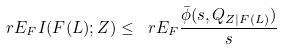Convert formula to latex. <formula><loc_0><loc_0><loc_500><loc_500>\ r E _ { F } I ( F ( L ) ; Z ) \leq \ r E _ { F } \frac { \bar { \phi } ( s , Q _ { Z | F ( L ) } ) } { s }</formula> 